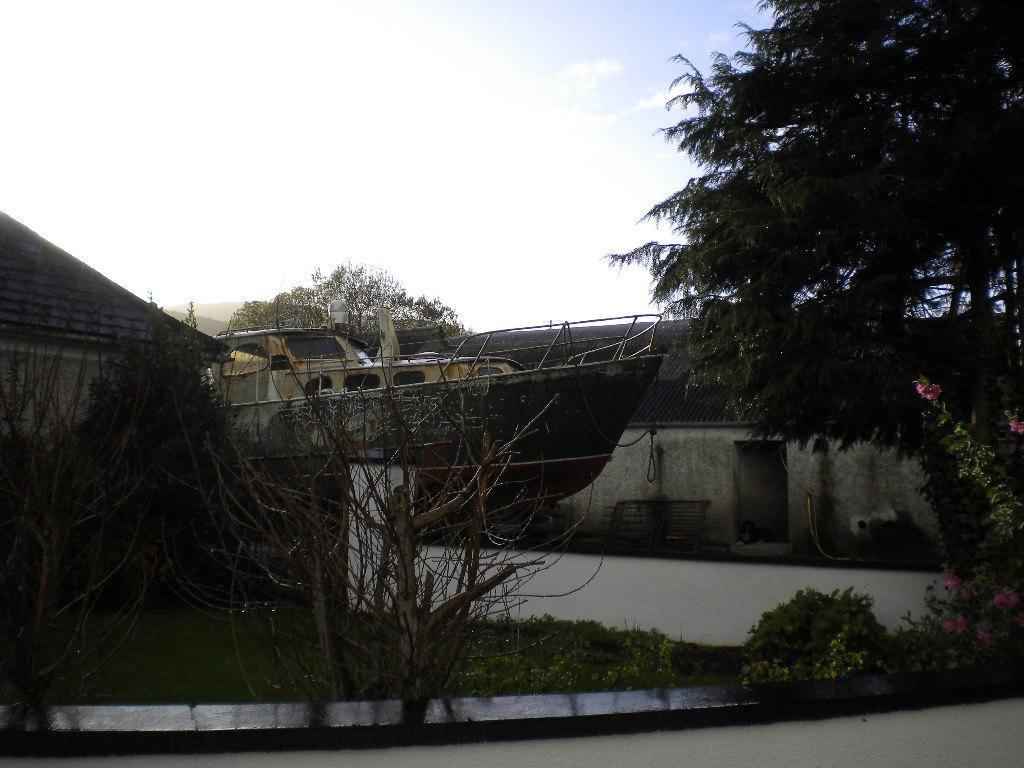Describe this image in one or two sentences. This picture is clicked outside. In the center we can see an object on top of the tree and we can see the plants and grass and we can see the flowers and a tree. In the background we can see the sky and some houses. 